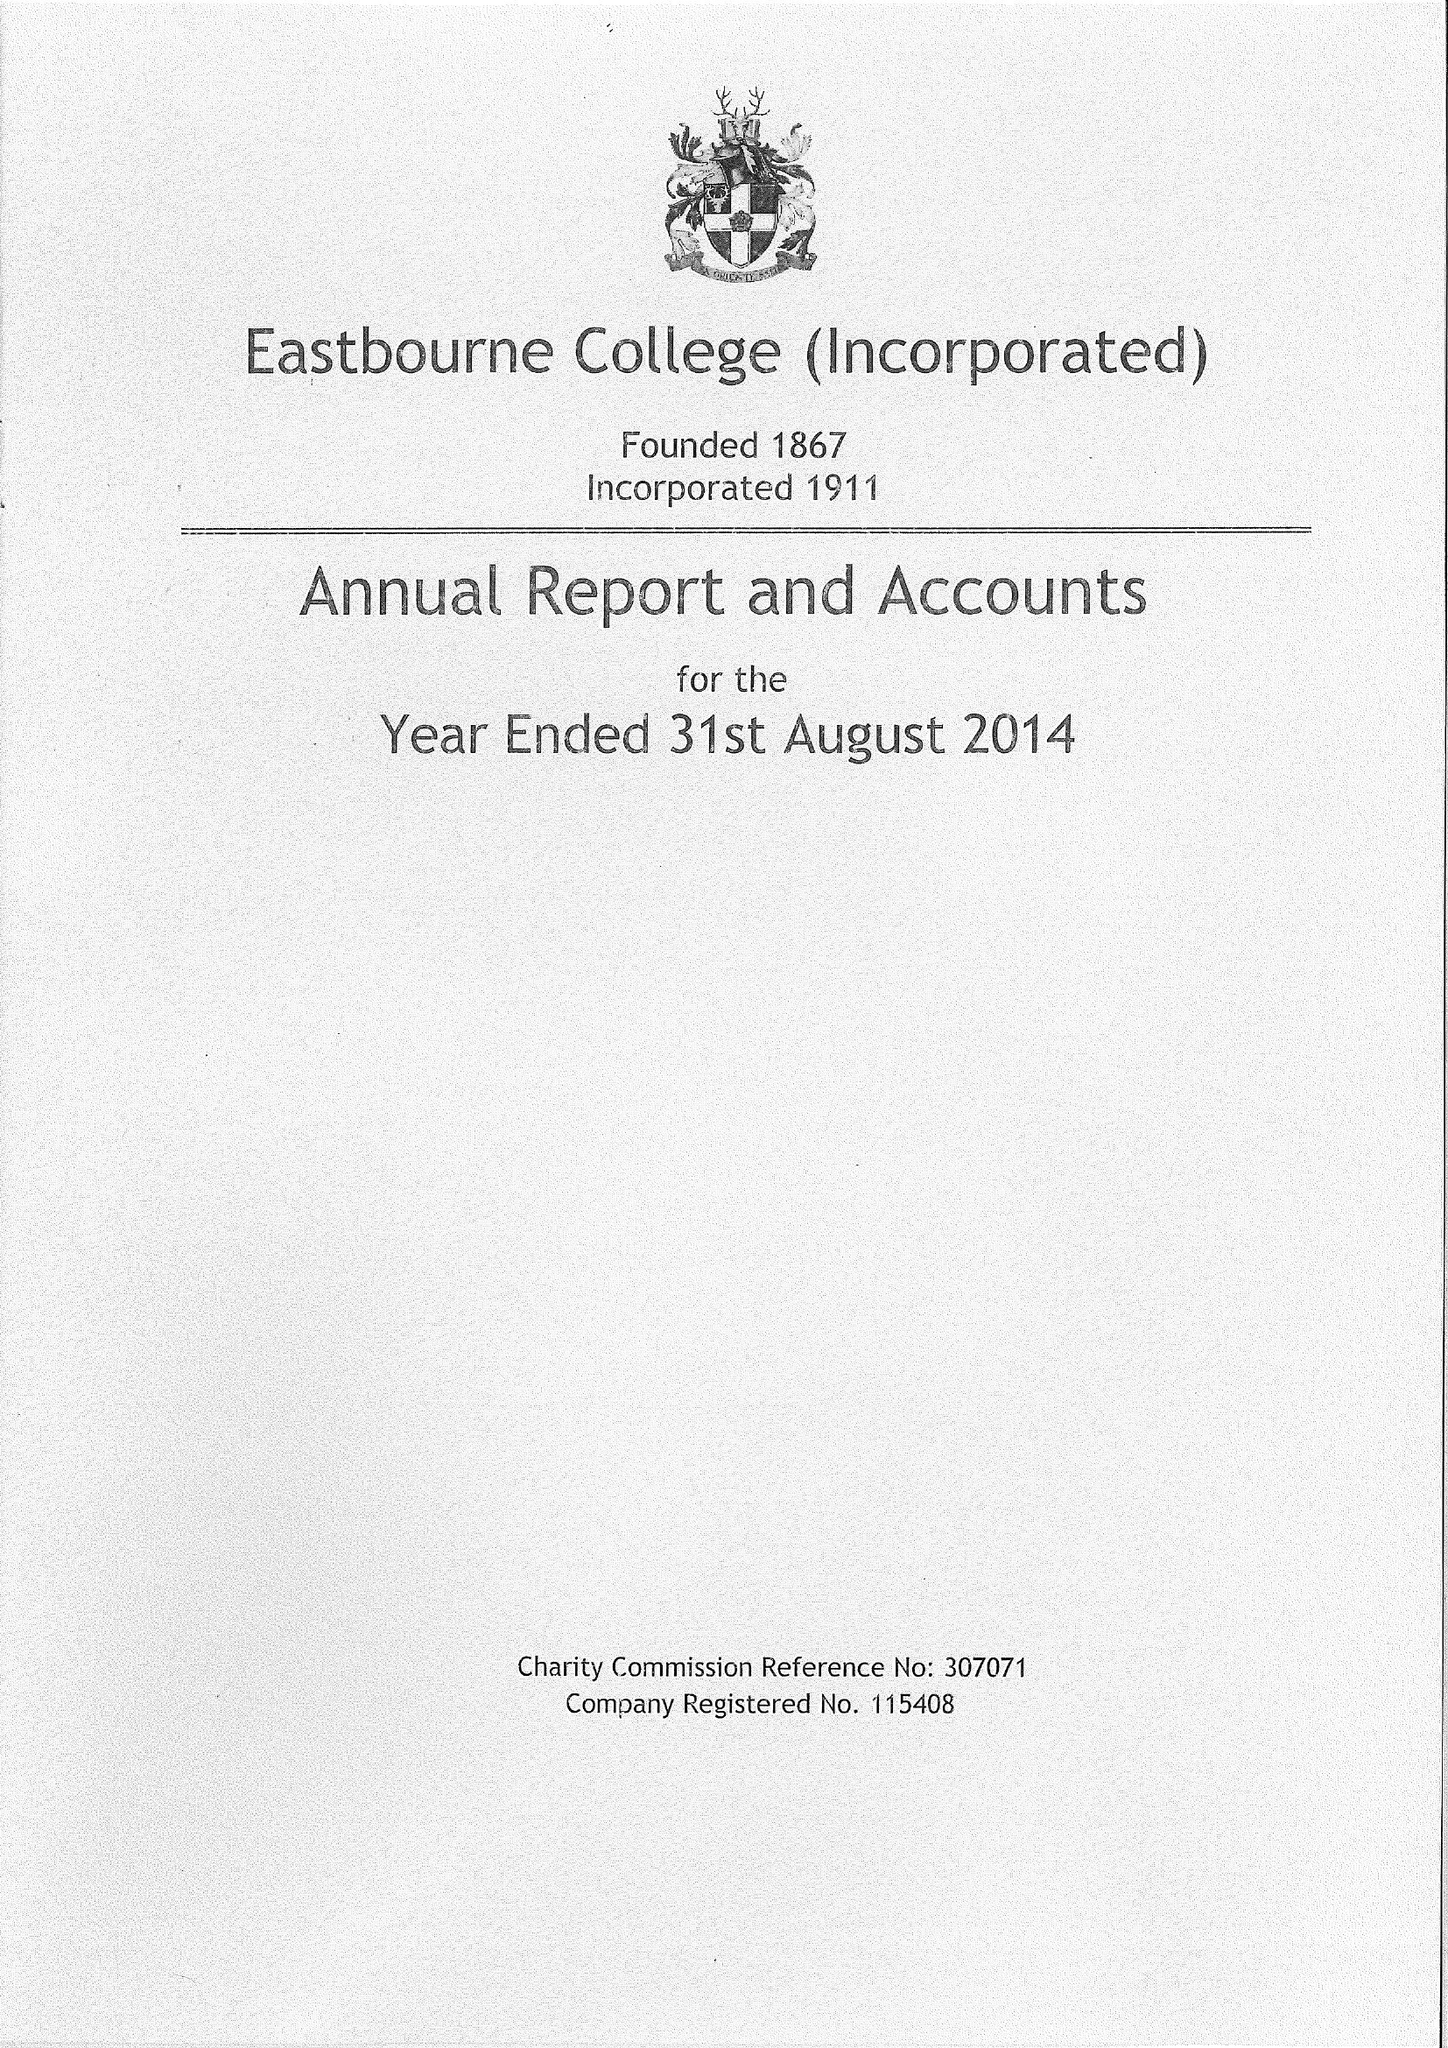What is the value for the charity_number?
Answer the question using a single word or phrase. 307071 